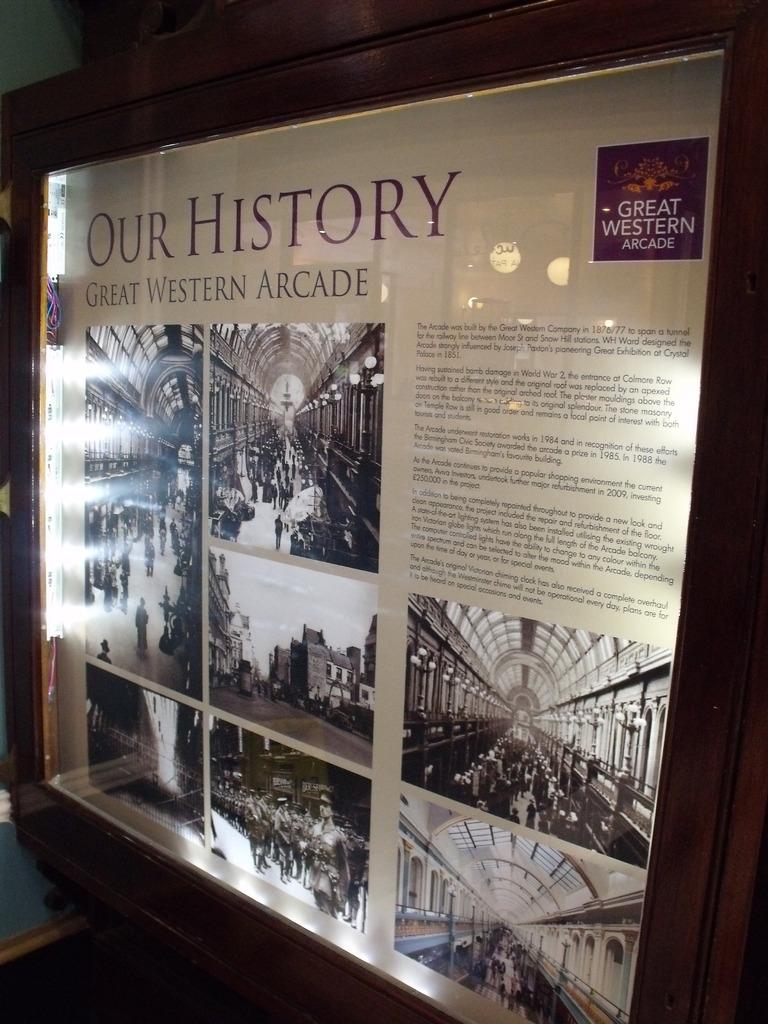Which arcade sponsor's the exhibit?
Make the answer very short. Great western. What does this exhibit document?
Your response must be concise. Our history. 